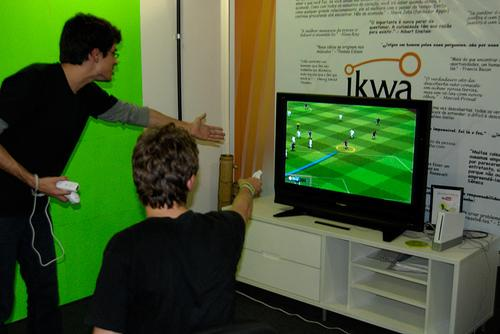What do these young people pretend to do? play soccer 